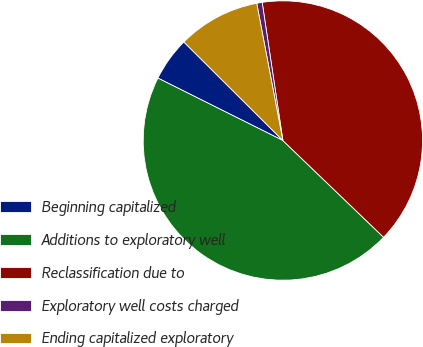Convert chart to OTSL. <chart><loc_0><loc_0><loc_500><loc_500><pie_chart><fcel>Beginning capitalized<fcel>Additions to exploratory well<fcel>Reclassification due to<fcel>Exploratory well costs charged<fcel>Ending capitalized exploratory<nl><fcel>5.09%<fcel>45.19%<fcel>39.55%<fcel>0.63%<fcel>9.54%<nl></chart> 